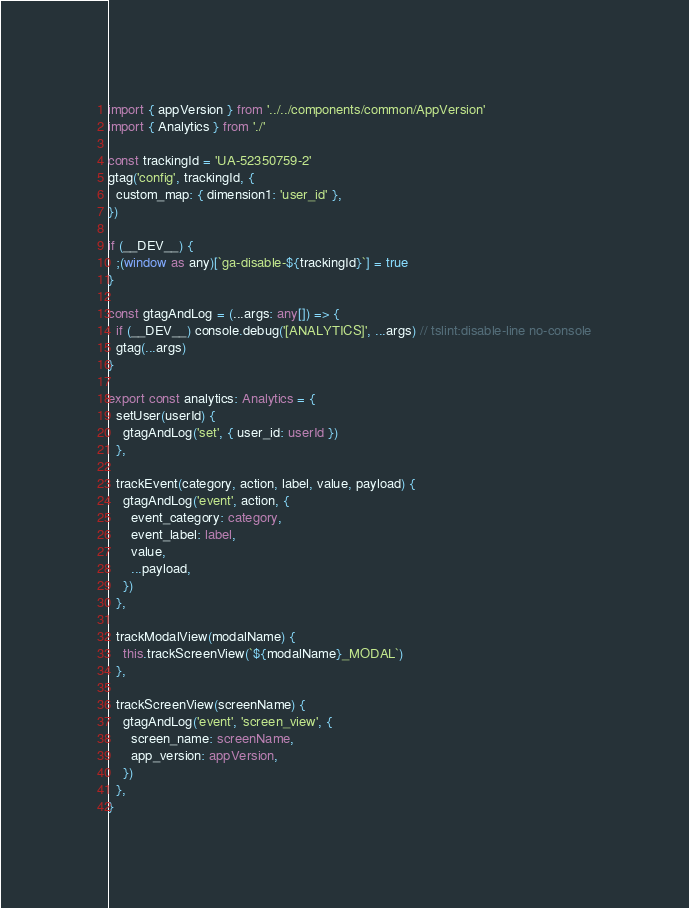<code> <loc_0><loc_0><loc_500><loc_500><_TypeScript_>import { appVersion } from '../../components/common/AppVersion'
import { Analytics } from './'

const trackingId = 'UA-52350759-2'
gtag('config', trackingId, {
  custom_map: { dimension1: 'user_id' },
})

if (__DEV__) {
  ;(window as any)[`ga-disable-${trackingId}`] = true
}

const gtagAndLog = (...args: any[]) => {
  if (__DEV__) console.debug('[ANALYTICS]', ...args) // tslint:disable-line no-console
  gtag(...args)
}

export const analytics: Analytics = {
  setUser(userId) {
    gtagAndLog('set', { user_id: userId })
  },

  trackEvent(category, action, label, value, payload) {
    gtagAndLog('event', action, {
      event_category: category,
      event_label: label,
      value,
      ...payload,
    })
  },

  trackModalView(modalName) {
    this.trackScreenView(`${modalName}_MODAL`)
  },

  trackScreenView(screenName) {
    gtagAndLog('event', 'screen_view', {
      screen_name: screenName,
      app_version: appVersion,
    })
  },
}
</code> 